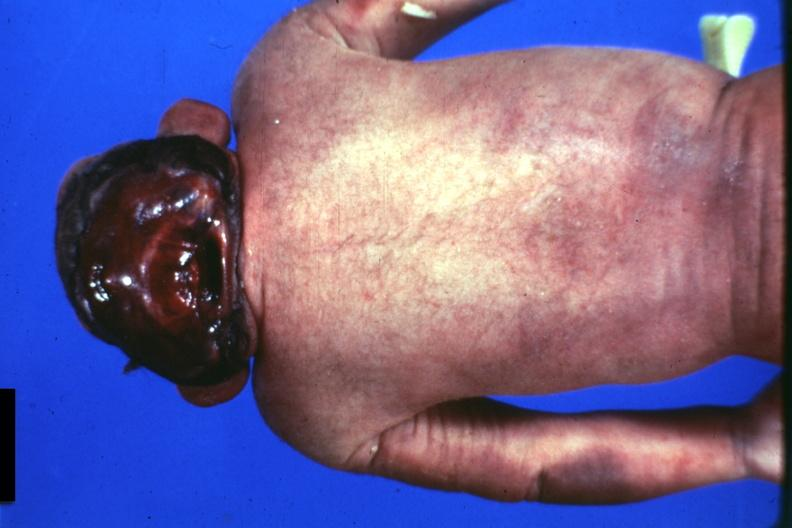what is present?
Answer the question using a single word or phrase. Anencephaly 